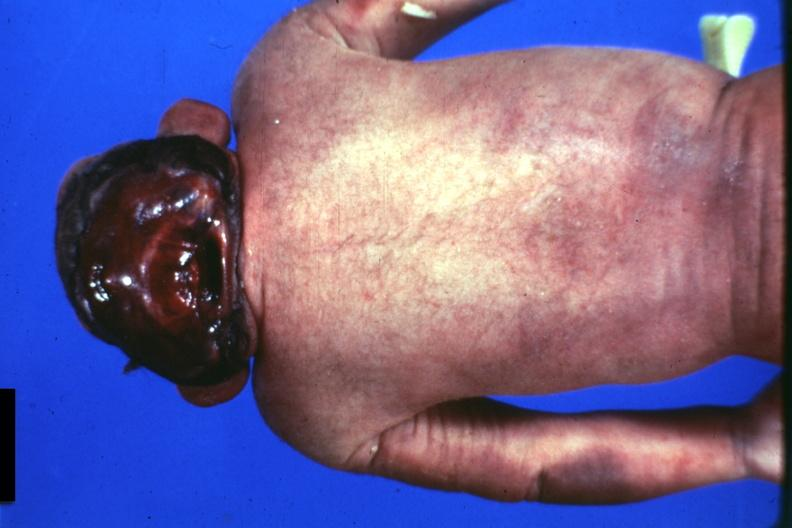what is present?
Answer the question using a single word or phrase. Anencephaly 